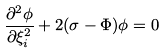Convert formula to latex. <formula><loc_0><loc_0><loc_500><loc_500>\frac { \partial ^ { 2 } \phi } { \partial \xi _ { i } ^ { 2 } } + 2 ( \sigma - \Phi ) \phi = 0</formula> 